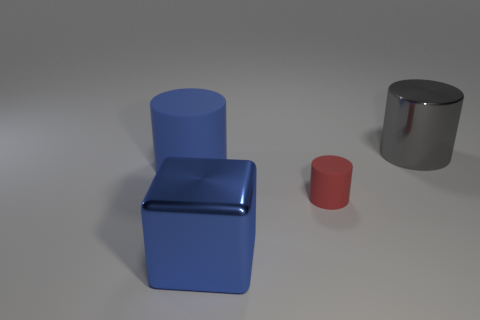Add 2 blue rubber things. How many objects exist? 6 Subtract all blocks. How many objects are left? 3 Add 1 small rubber things. How many small rubber things exist? 2 Subtract 0 yellow cubes. How many objects are left? 4 Subtract all blue cubes. Subtract all large blue cubes. How many objects are left? 2 Add 4 matte things. How many matte things are left? 6 